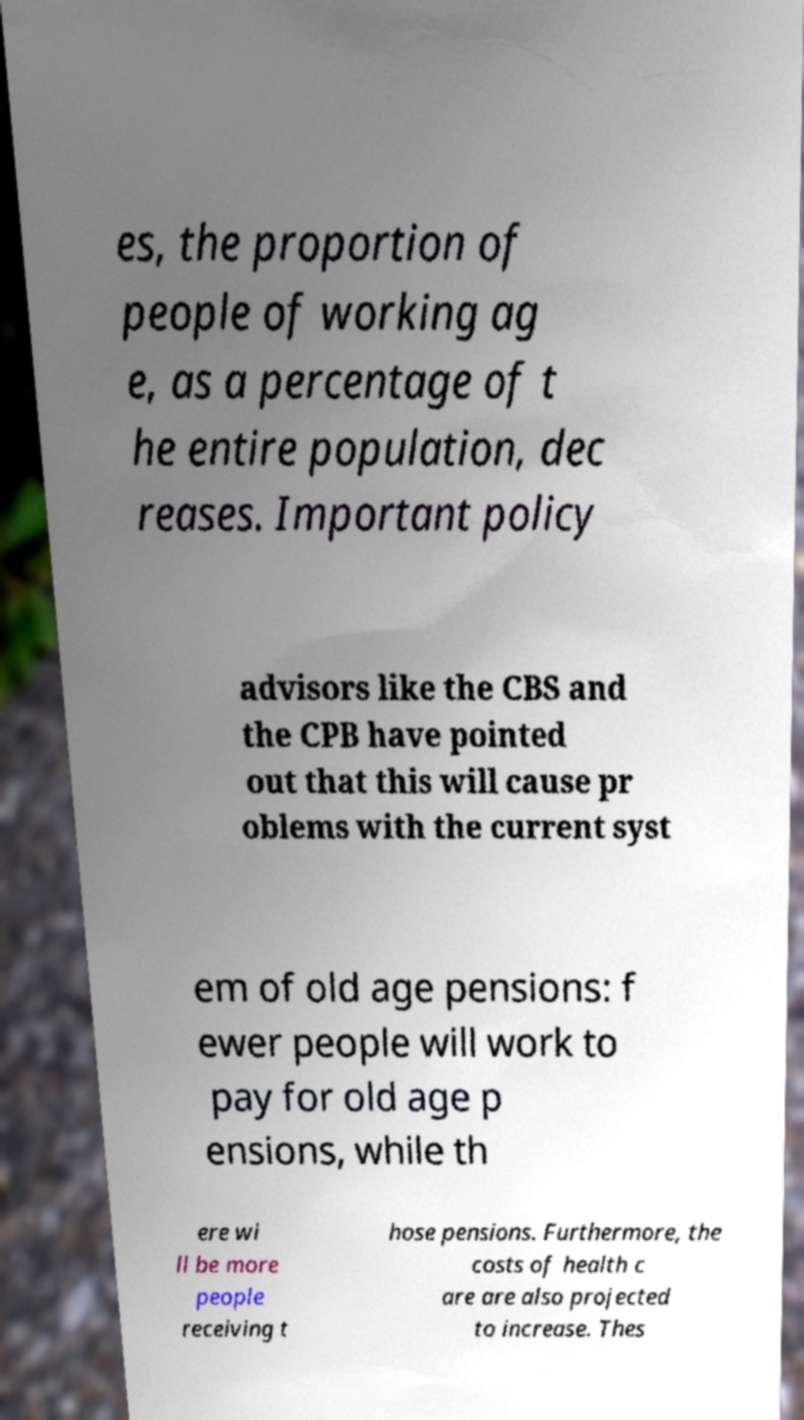Can you accurately transcribe the text from the provided image for me? es, the proportion of people of working ag e, as a percentage of t he entire population, dec reases. Important policy advisors like the CBS and the CPB have pointed out that this will cause pr oblems with the current syst em of old age pensions: f ewer people will work to pay for old age p ensions, while th ere wi ll be more people receiving t hose pensions. Furthermore, the costs of health c are are also projected to increase. Thes 